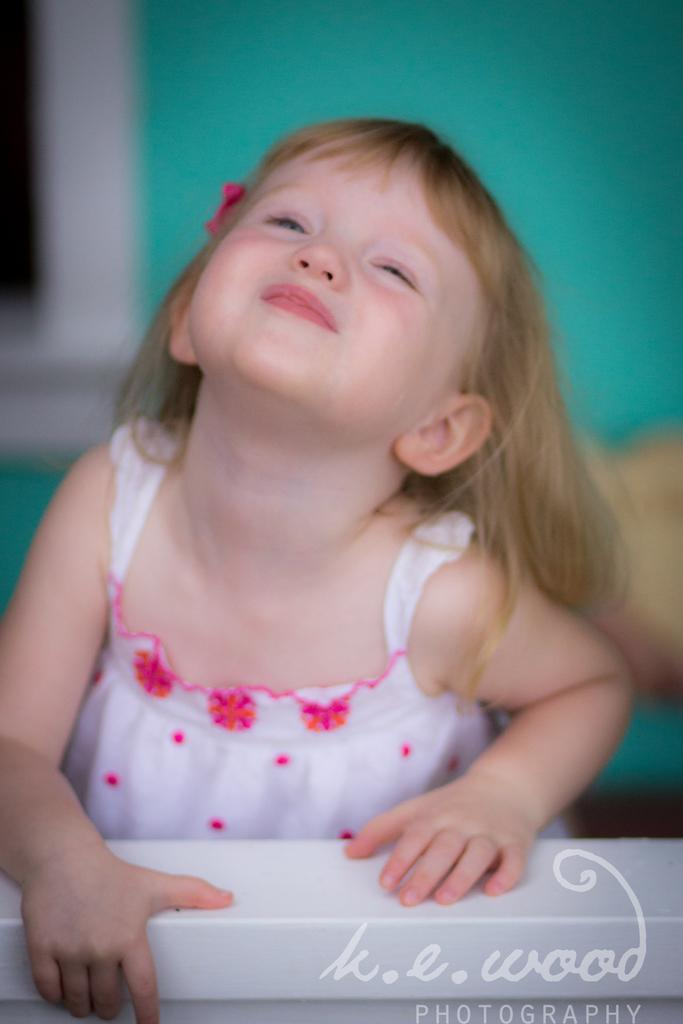What is the main subject of the image? There is an object in the image. Can you describe the girl in the image? There is a girl in the image, and she is smiling. How would you describe the background of the image? The background of the image is blurry. What else can be seen in the background of the image? There are objects and a wall in the background of the image. What type of cord is being used by the girl in the image? There is no cord visible in the image. How many sisters does the girl have in the image? There is no mention of sisters in the image. 